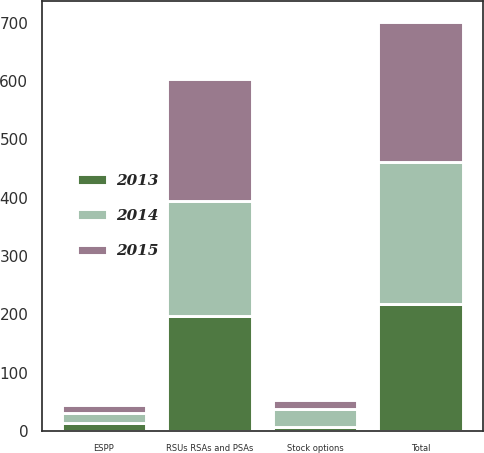Convert chart to OTSL. <chart><loc_0><loc_0><loc_500><loc_500><stacked_bar_chart><ecel><fcel>Stock options<fcel>RSUs RSAs and PSAs<fcel>ESPP<fcel>Total<nl><fcel>2013<fcel>6.6<fcel>197.3<fcel>13.4<fcel>217.3<nl><fcel>2015<fcel>14.9<fcel>209.7<fcel>15.4<fcel>240<nl><fcel>2014<fcel>31.5<fcel>196.8<fcel>16.3<fcel>244.6<nl></chart> 